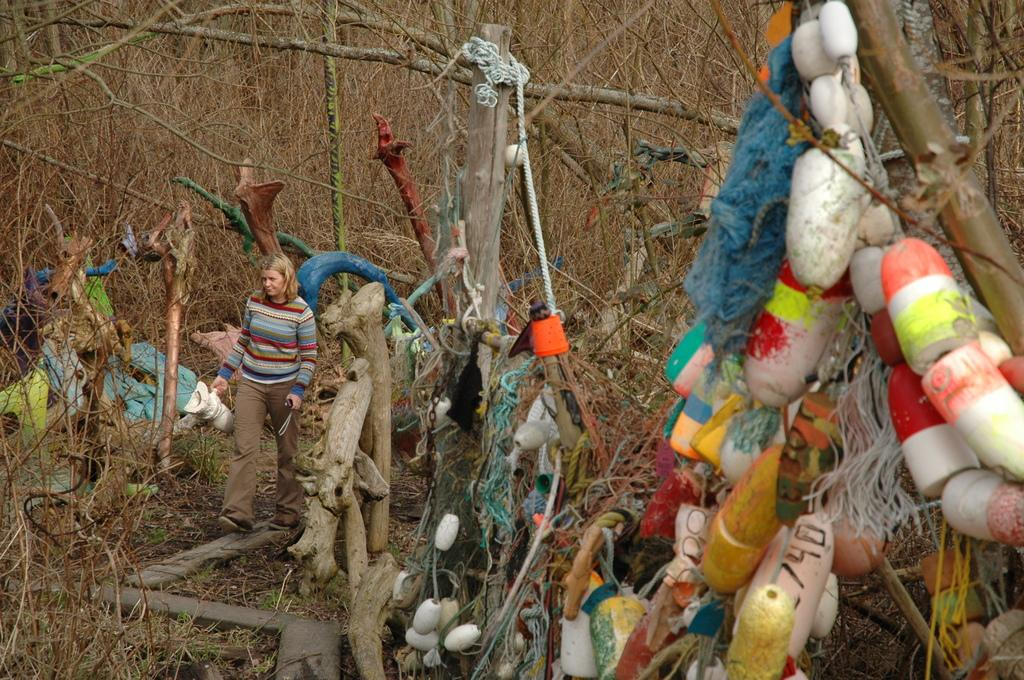Who is the main subject in the image? There is a lady in the image. Where is the lady located in the image? The lady is on the left side of the image. What type of setting is depicted in the image? The image appears to depict a woodland setting. What type of cherries can be seen in the market in the image? There is no market or cherries present in the image; it features a lady in a woodland setting. 